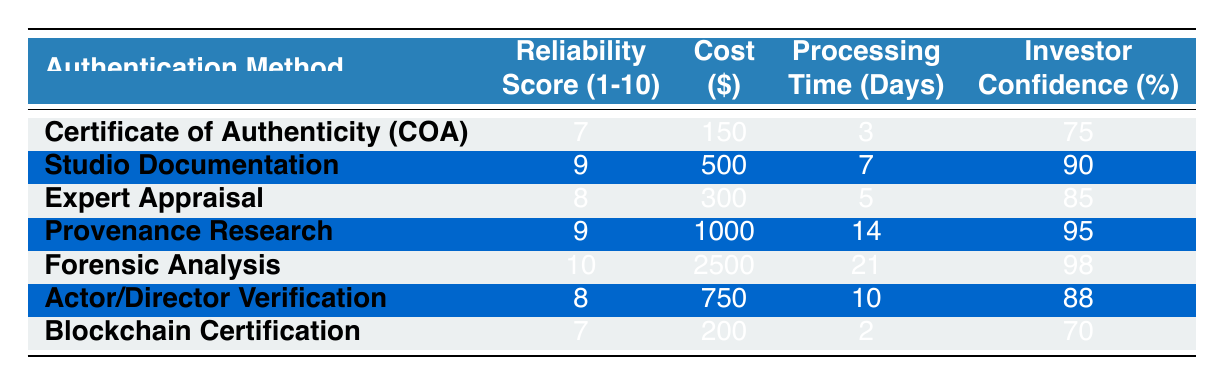What is the reliability score of Forensic Analysis? The reliability score for Forensic Analysis is listed directly in the table under the "Reliability Score (1-10)" column. According to the table, it is scored as 10.
Answer: 10 Which authentication method has the highest investor confidence? The investor confidence percentages are displayed in the table, and by comparing the values, we see that Provenance Research has the highest percentage at 95%.
Answer: Provenance Research How much does Expert Appraisal cost compared to Studio Documentation? To answer this, look at the "Cost ($)" column for both methods. Expert Appraisal costs $300, while Studio Documentation costs $500. The difference in cost is calculated as $500 - $300 = $200.
Answer: $200 Is the reliability score of Certificate of Authenticity higher than that of Blockchain Certification? The reliability scores are 7 for Certificate of Authenticity and 7 for Blockchain Certification. Since both are equal, the answer is no, Certificate of Authenticity is not higher.
Answer: No What is the average processing time for all the authentication methods? To find the average processing time, we sum all the values in the "Processing Time (Days)" column: 3 + 7 + 5 + 14 + 21 + 10 + 2 = 62. There are 7 methods, so we calculate the average as 62 / 7, which is approximately 8.86 days.
Answer: 8.86 Which authentication method is the least expensive? We need to look at the "Cost ($)" column and find the lowest value. The lowest cost is $150 for the Certificate of Authenticity.
Answer: Certificate of Authenticity If an investor wants the highest reliability score but also the lowest cost, which method should they choose? We look for the authentication methods that have the highest reliability score and compare their costs. Forensic Analysis has the highest reliability score of 10 but costs $2500. The next highest is Expert Appraisal with a score of 8 at $300, which is much lower, making it the better choice for the investor.
Answer: Expert Appraisal Do any authentication methods have the same reliability score? By examining the "Reliability Score (1-10)" column, we see that Certificate of Authenticity and Blockchain Certification both have a score of 7, which confirms that there are methods with the same reliability score.
Answer: Yes 